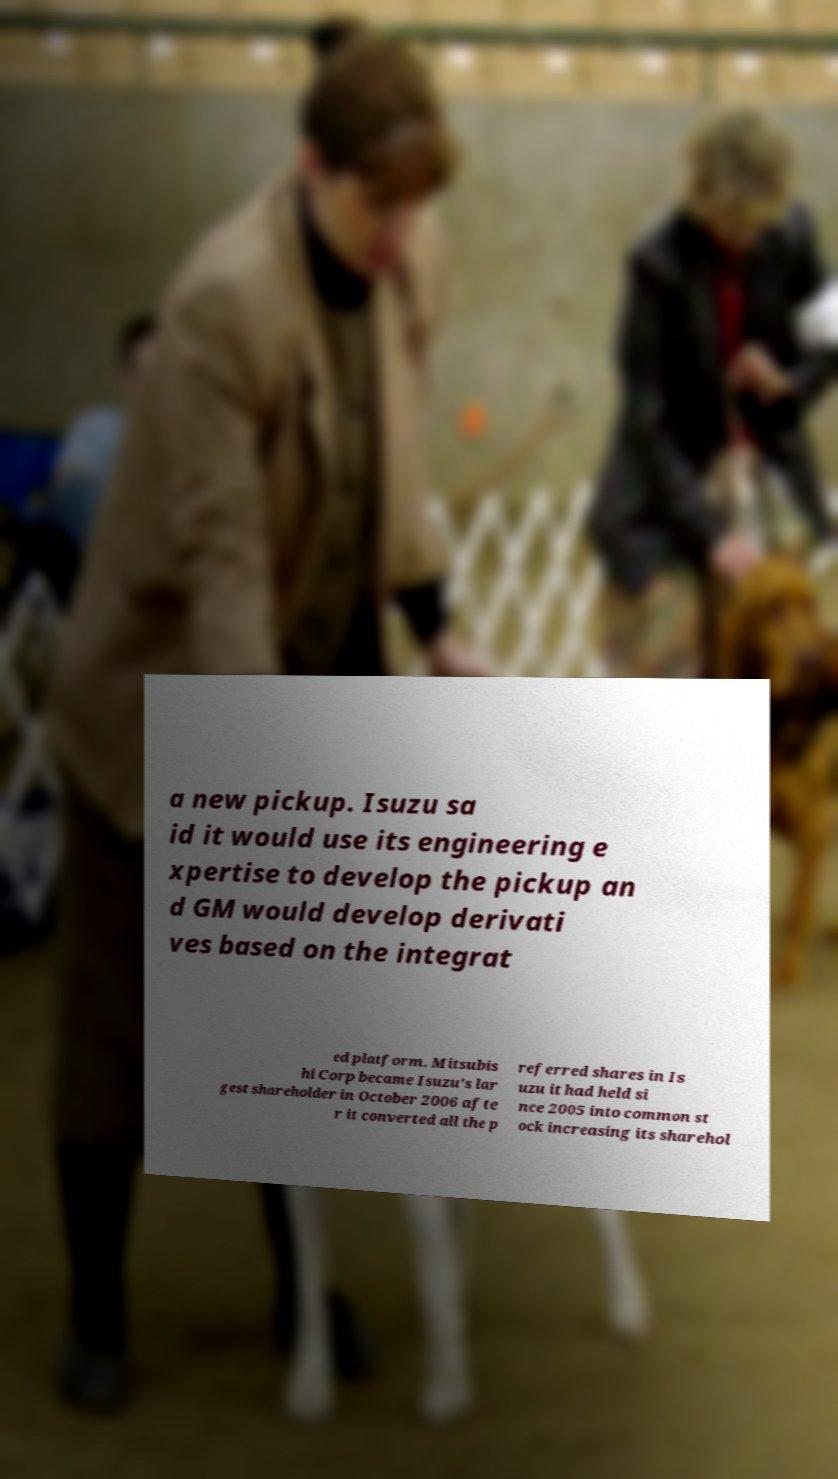I need the written content from this picture converted into text. Can you do that? a new pickup. Isuzu sa id it would use its engineering e xpertise to develop the pickup an d GM would develop derivati ves based on the integrat ed platform. Mitsubis hi Corp became Isuzu's lar gest shareholder in October 2006 afte r it converted all the p referred shares in Is uzu it had held si nce 2005 into common st ock increasing its sharehol 